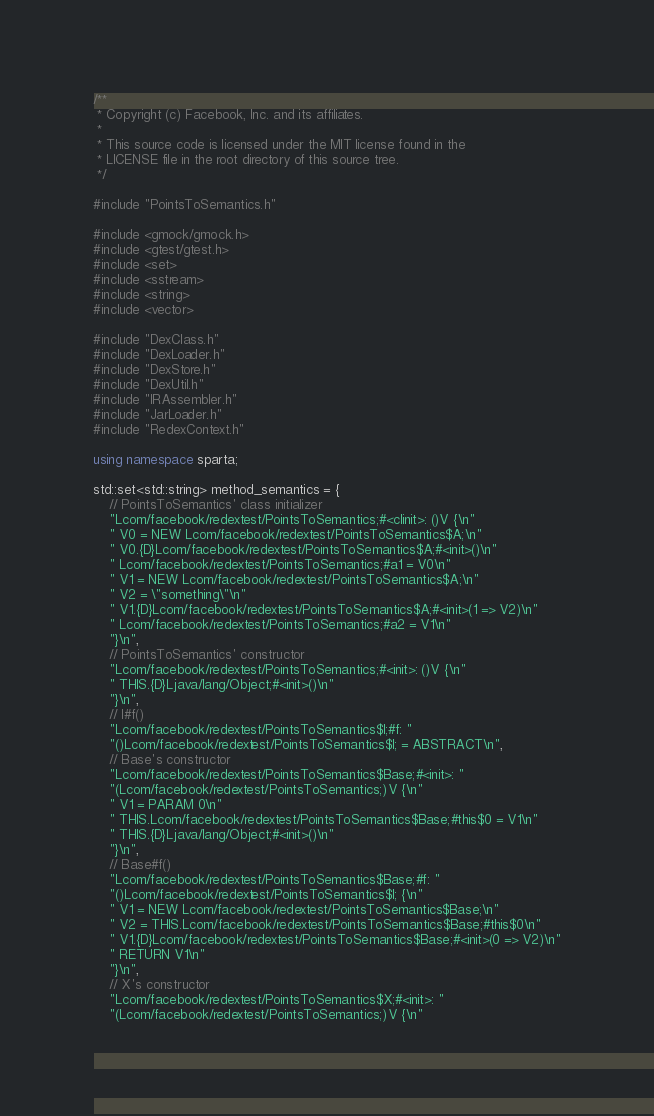<code> <loc_0><loc_0><loc_500><loc_500><_C++_>/**
 * Copyright (c) Facebook, Inc. and its affiliates.
 *
 * This source code is licensed under the MIT license found in the
 * LICENSE file in the root directory of this source tree.
 */

#include "PointsToSemantics.h"

#include <gmock/gmock.h>
#include <gtest/gtest.h>
#include <set>
#include <sstream>
#include <string>
#include <vector>

#include "DexClass.h"
#include "DexLoader.h"
#include "DexStore.h"
#include "DexUtil.h"
#include "IRAssembler.h"
#include "JarLoader.h"
#include "RedexContext.h"

using namespace sparta;

std::set<std::string> method_semantics = {
    // PointsToSemantics' class initializer
    "Lcom/facebook/redextest/PointsToSemantics;#<clinit>: ()V {\n"
    " V0 = NEW Lcom/facebook/redextest/PointsToSemantics$A;\n"
    " V0.{D}Lcom/facebook/redextest/PointsToSemantics$A;#<init>()\n"
    " Lcom/facebook/redextest/PointsToSemantics;#a1 = V0\n"
    " V1 = NEW Lcom/facebook/redextest/PointsToSemantics$A;\n"
    " V2 = \"something\"\n"
    " V1.{D}Lcom/facebook/redextest/PointsToSemantics$A;#<init>(1 => V2)\n"
    " Lcom/facebook/redextest/PointsToSemantics;#a2 = V1\n"
    "}\n",
    // PointsToSemantics' constructor
    "Lcom/facebook/redextest/PointsToSemantics;#<init>: ()V {\n"
    " THIS.{D}Ljava/lang/Object;#<init>()\n"
    "}\n",
    // I#f()
    "Lcom/facebook/redextest/PointsToSemantics$I;#f: "
    "()Lcom/facebook/redextest/PointsToSemantics$I; = ABSTRACT\n",
    // Base's constructor
    "Lcom/facebook/redextest/PointsToSemantics$Base;#<init>: "
    "(Lcom/facebook/redextest/PointsToSemantics;)V {\n"
    " V1 = PARAM 0\n"
    " THIS.Lcom/facebook/redextest/PointsToSemantics$Base;#this$0 = V1\n"
    " THIS.{D}Ljava/lang/Object;#<init>()\n"
    "}\n",
    // Base#f()
    "Lcom/facebook/redextest/PointsToSemantics$Base;#f: "
    "()Lcom/facebook/redextest/PointsToSemantics$I; {\n"
    " V1 = NEW Lcom/facebook/redextest/PointsToSemantics$Base;\n"
    " V2 = THIS.Lcom/facebook/redextest/PointsToSemantics$Base;#this$0\n"
    " V1.{D}Lcom/facebook/redextest/PointsToSemantics$Base;#<init>(0 => V2)\n"
    " RETURN V1\n"
    "}\n",
    // X's constructor
    "Lcom/facebook/redextest/PointsToSemantics$X;#<init>: "
    "(Lcom/facebook/redextest/PointsToSemantics;)V {\n"</code> 